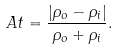Convert formula to latex. <formula><loc_0><loc_0><loc_500><loc_500>A t = \frac { | \rho _ { o } - \rho _ { i } | } { \rho _ { o } + \rho _ { i } } .</formula> 